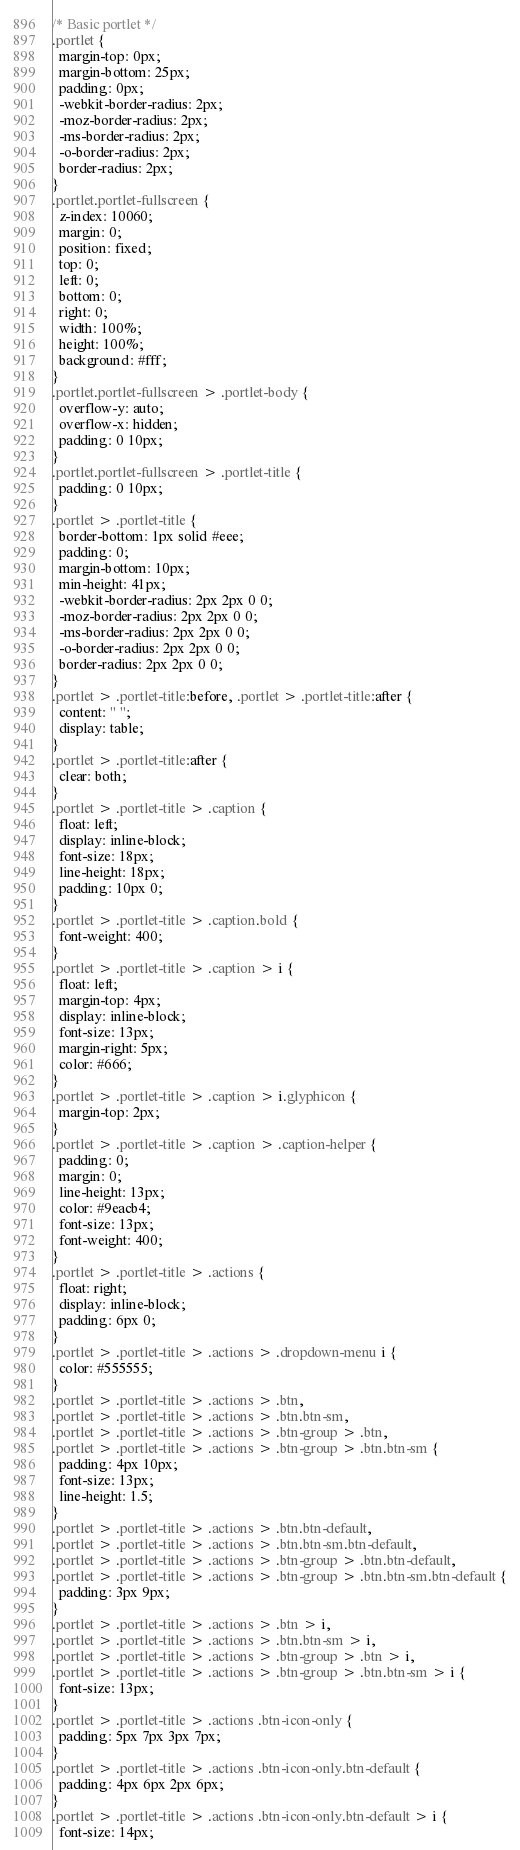<code> <loc_0><loc_0><loc_500><loc_500><_CSS_>/* Basic portlet */
.portlet {
  margin-top: 0px;
  margin-bottom: 25px;
  padding: 0px;
  -webkit-border-radius: 2px;
  -moz-border-radius: 2px;
  -ms-border-radius: 2px;
  -o-border-radius: 2px;
  border-radius: 2px;
}
.portlet.portlet-fullscreen {
  z-index: 10060;
  margin: 0;
  position: fixed;
  top: 0;
  left: 0;
  bottom: 0;
  right: 0;
  width: 100%;
  height: 100%;
  background: #fff;
}
.portlet.portlet-fullscreen > .portlet-body {
  overflow-y: auto;
  overflow-x: hidden;
  padding: 0 10px;
}
.portlet.portlet-fullscreen > .portlet-title {
  padding: 0 10px;
}
.portlet > .portlet-title {
  border-bottom: 1px solid #eee;
  padding: 0;
  margin-bottom: 10px;
  min-height: 41px;
  -webkit-border-radius: 2px 2px 0 0;
  -moz-border-radius: 2px 2px 0 0;
  -ms-border-radius: 2px 2px 0 0;
  -o-border-radius: 2px 2px 0 0;
  border-radius: 2px 2px 0 0;
}
.portlet > .portlet-title:before, .portlet > .portlet-title:after {
  content: " ";
  display: table;
}
.portlet > .portlet-title:after {
  clear: both;
}
.portlet > .portlet-title > .caption {
  float: left;
  display: inline-block;
  font-size: 18px;
  line-height: 18px;
  padding: 10px 0;
}
.portlet > .portlet-title > .caption.bold {
  font-weight: 400;
}
.portlet > .portlet-title > .caption > i {
  float: left;
  margin-top: 4px;
  display: inline-block;
  font-size: 13px;
  margin-right: 5px;
  color: #666;
}
.portlet > .portlet-title > .caption > i.glyphicon {
  margin-top: 2px;
}
.portlet > .portlet-title > .caption > .caption-helper {
  padding: 0;
  margin: 0;
  line-height: 13px;
  color: #9eacb4;
  font-size: 13px;
  font-weight: 400;
}
.portlet > .portlet-title > .actions {
  float: right;
  display: inline-block;
  padding: 6px 0;
}
.portlet > .portlet-title > .actions > .dropdown-menu i {
  color: #555555;
}
.portlet > .portlet-title > .actions > .btn,
.portlet > .portlet-title > .actions > .btn.btn-sm,
.portlet > .portlet-title > .actions > .btn-group > .btn,
.portlet > .portlet-title > .actions > .btn-group > .btn.btn-sm {
  padding: 4px 10px;
  font-size: 13px;
  line-height: 1.5;
}
.portlet > .portlet-title > .actions > .btn.btn-default,
.portlet > .portlet-title > .actions > .btn.btn-sm.btn-default,
.portlet > .portlet-title > .actions > .btn-group > .btn.btn-default,
.portlet > .portlet-title > .actions > .btn-group > .btn.btn-sm.btn-default {
  padding: 3px 9px;
}
.portlet > .portlet-title > .actions > .btn > i,
.portlet > .portlet-title > .actions > .btn.btn-sm > i,
.portlet > .portlet-title > .actions > .btn-group > .btn > i,
.portlet > .portlet-title > .actions > .btn-group > .btn.btn-sm > i {
  font-size: 13px;
}
.portlet > .portlet-title > .actions .btn-icon-only {
  padding: 5px 7px 3px 7px;
}
.portlet > .portlet-title > .actions .btn-icon-only.btn-default {
  padding: 4px 6px 2px 6px;
}
.portlet > .portlet-title > .actions .btn-icon-only.btn-default > i {
  font-size: 14px;</code> 